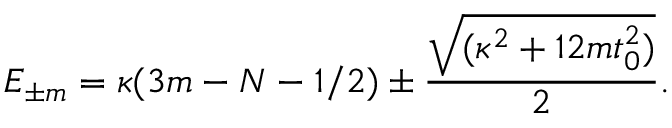<formula> <loc_0><loc_0><loc_500><loc_500>E _ { \pm m } = \kappa ( 3 m - N - 1 / 2 ) \pm \frac { \sqrt { ( \kappa ^ { 2 } + 1 2 m t _ { 0 } ^ { 2 } ) } } { 2 } .</formula> 